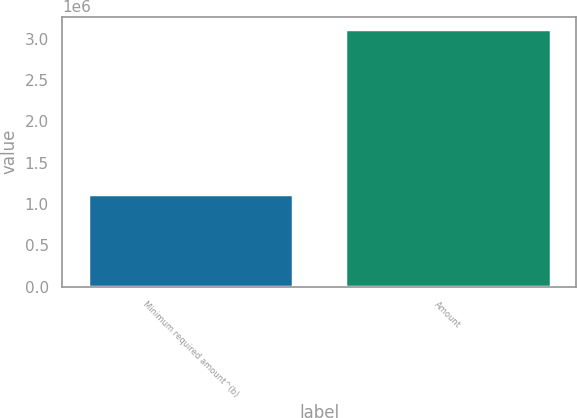<chart> <loc_0><loc_0><loc_500><loc_500><bar_chart><fcel>Minimum required amount^(b)<fcel>Amount<nl><fcel>1.12108e+06<fcel>3.11408e+06<nl></chart> 